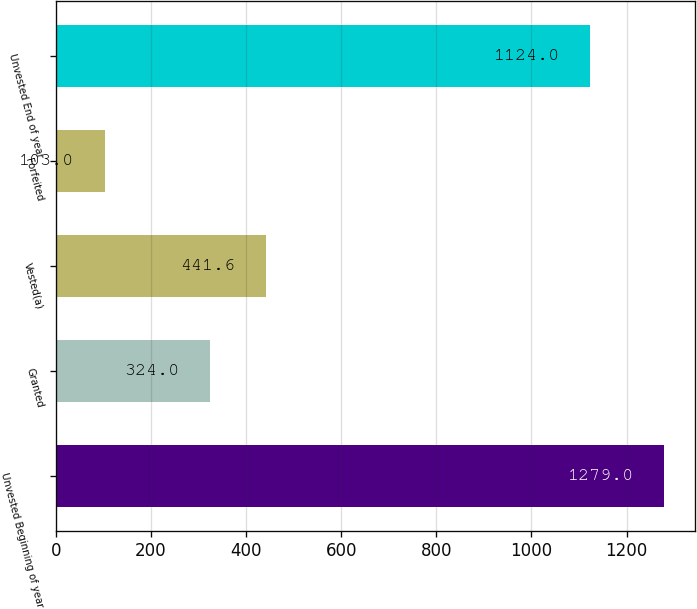<chart> <loc_0><loc_0><loc_500><loc_500><bar_chart><fcel>Unvested Beginning of year<fcel>Granted<fcel>Vested(a)<fcel>Forfeited<fcel>Unvested End of year<nl><fcel>1279<fcel>324<fcel>441.6<fcel>103<fcel>1124<nl></chart> 